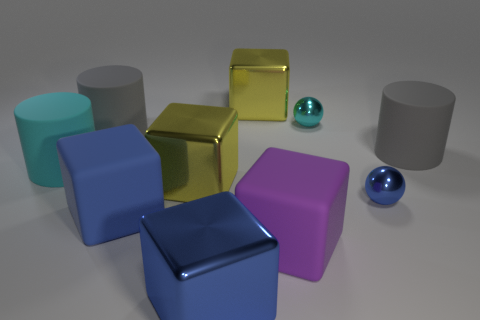Subtract all yellow spheres. How many blue blocks are left? 2 Subtract all cyan rubber cylinders. How many cylinders are left? 2 Subtract 3 cubes. How many cubes are left? 2 Subtract all purple cubes. How many cubes are left? 4 Subtract all cyan blocks. Subtract all purple cylinders. How many blocks are left? 5 Add 4 tiny blue objects. How many tiny blue objects exist? 5 Subtract 1 purple blocks. How many objects are left? 9 Subtract all balls. How many objects are left? 8 Subtract all big things. Subtract all big green rubber blocks. How many objects are left? 2 Add 3 large rubber cubes. How many large rubber cubes are left? 5 